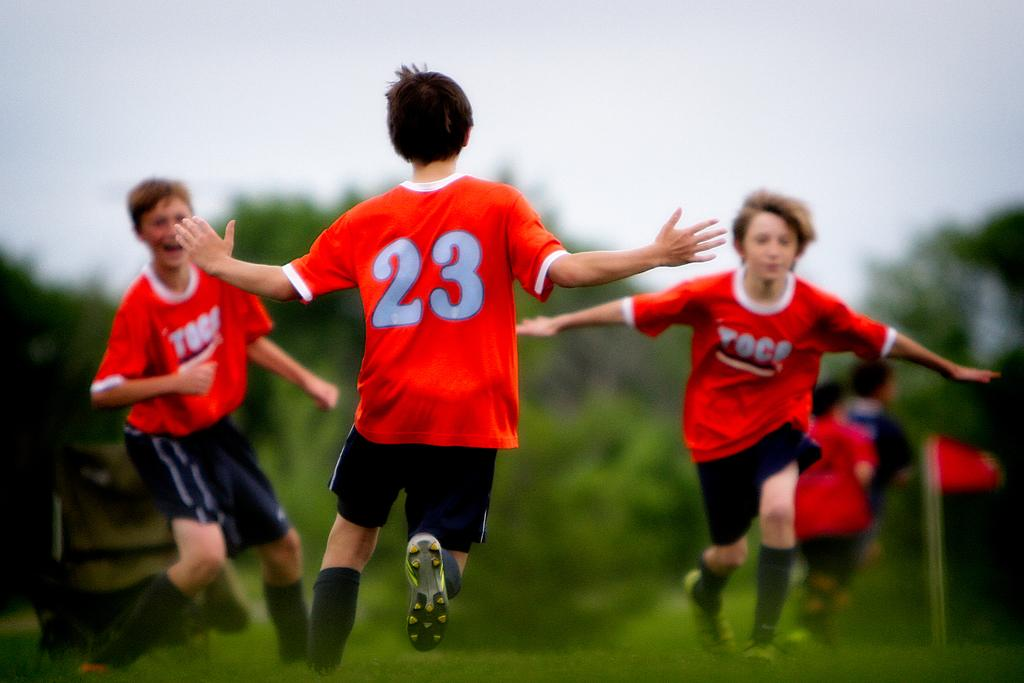What is the main subject of the image? The main subject of the image is a group of boys. What are the boys doing in the image? The boys are playing in the ground. What are the boys wearing in the image? The boys are wearing orange shirts. Can you describe the background of the image? The background of the image is blurry. What type of education can be seen on the canvas in the image? There is no canvas or education present in the image; it features a group of boys playing in the ground while wearing orange shirts. 